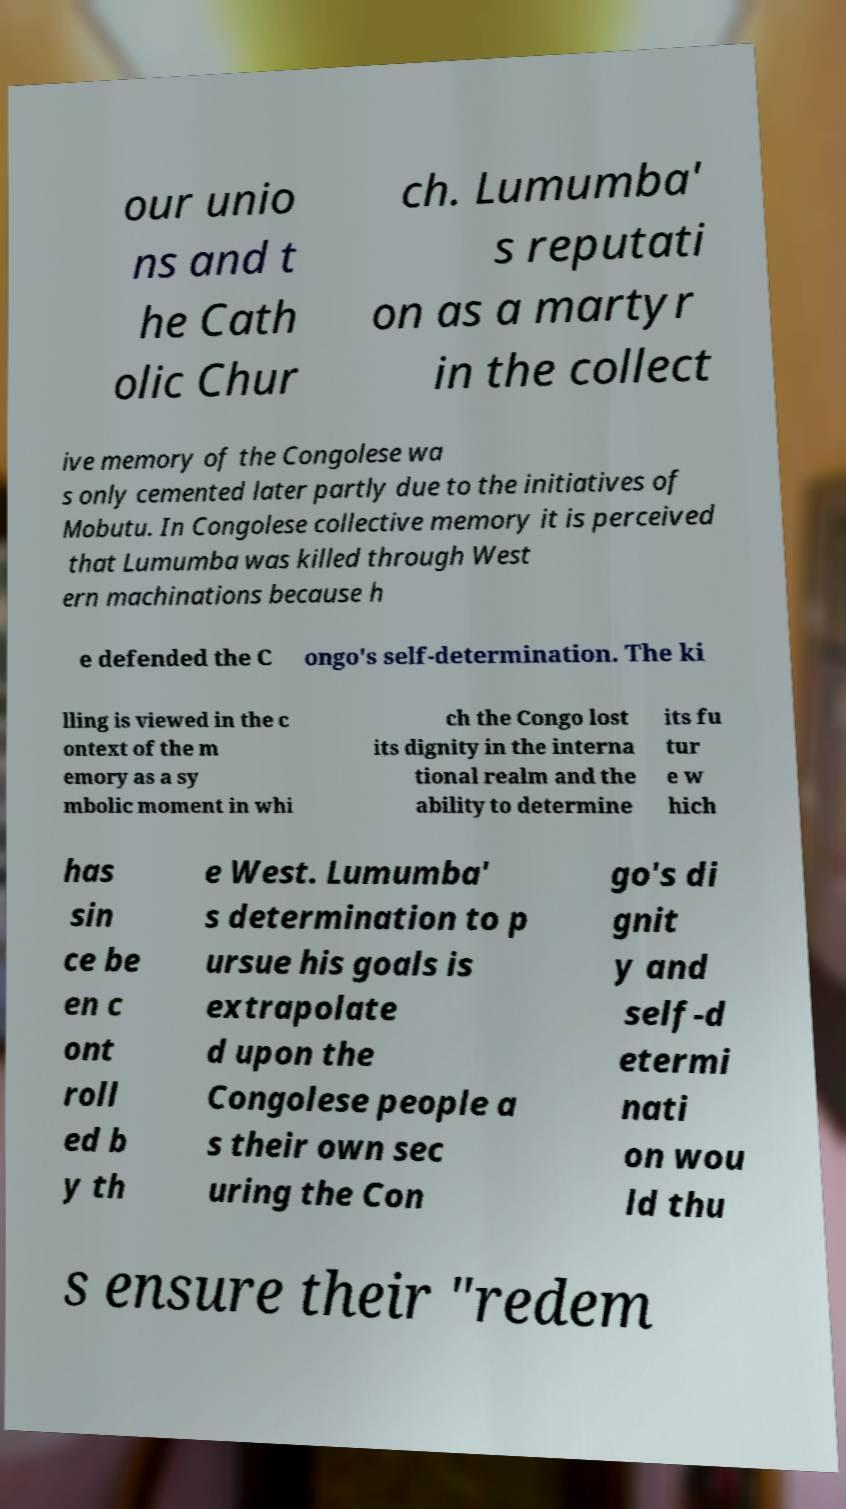Could you assist in decoding the text presented in this image and type it out clearly? our unio ns and t he Cath olic Chur ch. Lumumba' s reputati on as a martyr in the collect ive memory of the Congolese wa s only cemented later partly due to the initiatives of Mobutu. In Congolese collective memory it is perceived that Lumumba was killed through West ern machinations because h e defended the C ongo's self-determination. The ki lling is viewed in the c ontext of the m emory as a sy mbolic moment in whi ch the Congo lost its dignity in the interna tional realm and the ability to determine its fu tur e w hich has sin ce be en c ont roll ed b y th e West. Lumumba' s determination to p ursue his goals is extrapolate d upon the Congolese people a s their own sec uring the Con go's di gnit y and self-d etermi nati on wou ld thu s ensure their "redem 